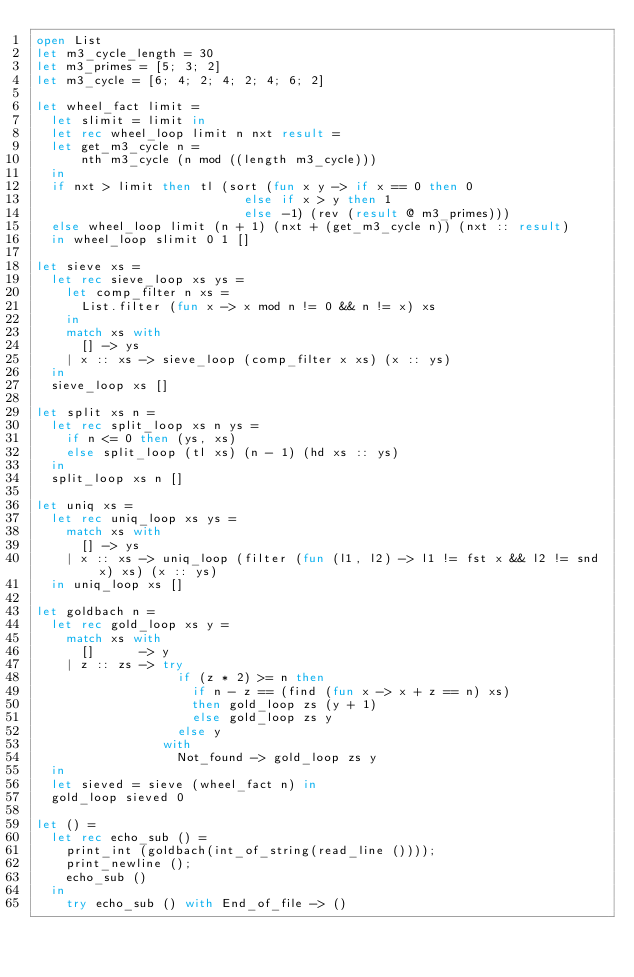Convert code to text. <code><loc_0><loc_0><loc_500><loc_500><_OCaml_>open List
let m3_cycle_length = 30
let m3_primes = [5; 3; 2]
let m3_cycle = [6; 4; 2; 4; 2; 4; 6; 2]

let wheel_fact limit =
  let slimit = limit in
  let rec wheel_loop limit n nxt result =
  let get_m3_cycle n =
      nth m3_cycle (n mod ((length m3_cycle)))
  in
  if nxt > limit then tl (sort (fun x y -> if x == 0 then 0
                            else if x > y then 1
                            else -1) (rev (result @ m3_primes)))
  else wheel_loop limit (n + 1) (nxt + (get_m3_cycle n)) (nxt :: result)
  in wheel_loop slimit 0 1 []

let sieve xs =
  let rec sieve_loop xs ys =
    let comp_filter n xs = 
      List.filter (fun x -> x mod n != 0 && n != x) xs 
    in 
    match xs with
      [] -> ys
    | x :: xs -> sieve_loop (comp_filter x xs) (x :: ys)
  in
  sieve_loop xs []

let split xs n =
  let rec split_loop xs n ys =
    if n <= 0 then (ys, xs)
    else split_loop (tl xs) (n - 1) (hd xs :: ys)
  in
  split_loop xs n []

let uniq xs =
  let rec uniq_loop xs ys =
    match xs with
      [] -> ys
    | x :: xs -> uniq_loop (filter (fun (l1, l2) -> l1 != fst x && l2 != snd x) xs) (x :: ys)
  in uniq_loop xs []

let goldbach n =
  let rec gold_loop xs y =
    match xs with
      []      -> y
    | z :: zs -> try
                   if (z * 2) >= n then 
                     if n - z == (find (fun x -> x + z == n) xs)
                     then gold_loop zs (y + 1)
                     else gold_loop zs y
                   else y
                 with
                   Not_found -> gold_loop zs y
  in
  let sieved = sieve (wheel_fact n) in
  gold_loop sieved 0

let () =
  let rec echo_sub () =
    print_int (goldbach(int_of_string(read_line ())));
    print_newline ();
    echo_sub ()
  in
    try echo_sub () with End_of_file -> ()</code> 